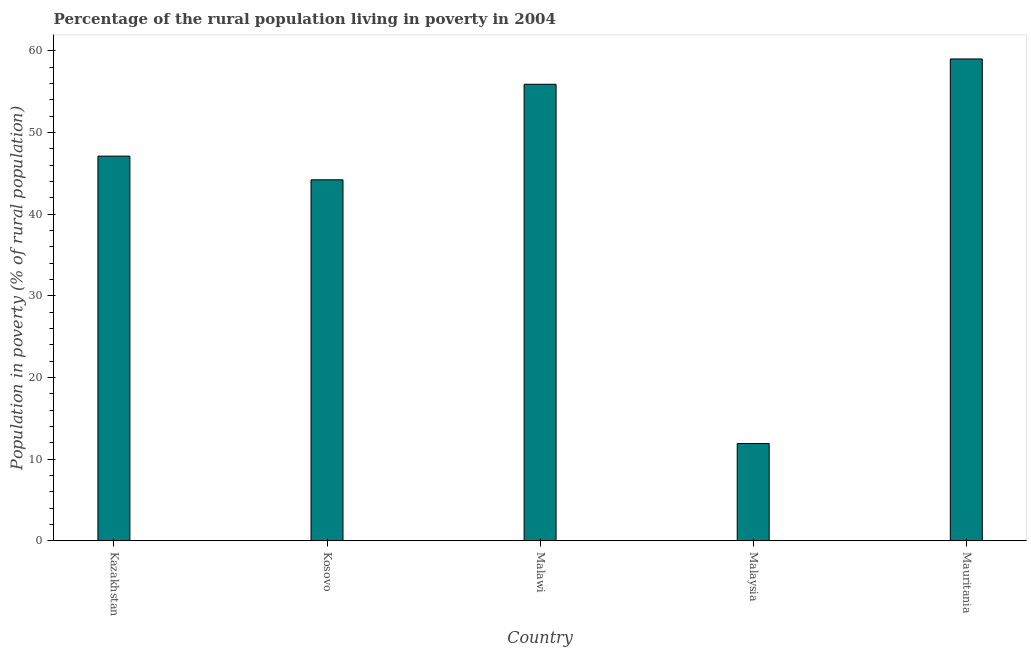Does the graph contain grids?
Your answer should be compact. No. What is the title of the graph?
Offer a very short reply. Percentage of the rural population living in poverty in 2004. What is the label or title of the X-axis?
Ensure brevity in your answer.  Country. What is the label or title of the Y-axis?
Offer a very short reply. Population in poverty (% of rural population). What is the percentage of rural population living below poverty line in Mauritania?
Offer a terse response. 59. Across all countries, what is the maximum percentage of rural population living below poverty line?
Provide a succinct answer. 59. Across all countries, what is the minimum percentage of rural population living below poverty line?
Your answer should be compact. 11.9. In which country was the percentage of rural population living below poverty line maximum?
Provide a succinct answer. Mauritania. In which country was the percentage of rural population living below poverty line minimum?
Keep it short and to the point. Malaysia. What is the sum of the percentage of rural population living below poverty line?
Offer a very short reply. 218.1. What is the difference between the percentage of rural population living below poverty line in Kazakhstan and Malaysia?
Give a very brief answer. 35.2. What is the average percentage of rural population living below poverty line per country?
Give a very brief answer. 43.62. What is the median percentage of rural population living below poverty line?
Offer a terse response. 47.1. What is the ratio of the percentage of rural population living below poverty line in Kosovo to that in Malawi?
Offer a terse response. 0.79. Is the percentage of rural population living below poverty line in Malaysia less than that in Mauritania?
Your answer should be very brief. Yes. Is the difference between the percentage of rural population living below poverty line in Malaysia and Mauritania greater than the difference between any two countries?
Give a very brief answer. Yes. What is the difference between the highest and the lowest percentage of rural population living below poverty line?
Your answer should be very brief. 47.1. In how many countries, is the percentage of rural population living below poverty line greater than the average percentage of rural population living below poverty line taken over all countries?
Make the answer very short. 4. How many countries are there in the graph?
Offer a very short reply. 5. What is the Population in poverty (% of rural population) of Kazakhstan?
Provide a short and direct response. 47.1. What is the Population in poverty (% of rural population) of Kosovo?
Your answer should be compact. 44.2. What is the Population in poverty (% of rural population) in Malawi?
Ensure brevity in your answer.  55.9. What is the difference between the Population in poverty (% of rural population) in Kazakhstan and Kosovo?
Make the answer very short. 2.9. What is the difference between the Population in poverty (% of rural population) in Kazakhstan and Malawi?
Provide a short and direct response. -8.8. What is the difference between the Population in poverty (% of rural population) in Kazakhstan and Malaysia?
Make the answer very short. 35.2. What is the difference between the Population in poverty (% of rural population) in Kosovo and Malawi?
Offer a terse response. -11.7. What is the difference between the Population in poverty (% of rural population) in Kosovo and Malaysia?
Make the answer very short. 32.3. What is the difference between the Population in poverty (% of rural population) in Kosovo and Mauritania?
Offer a very short reply. -14.8. What is the difference between the Population in poverty (% of rural population) in Malawi and Malaysia?
Offer a terse response. 44. What is the difference between the Population in poverty (% of rural population) in Malaysia and Mauritania?
Provide a succinct answer. -47.1. What is the ratio of the Population in poverty (% of rural population) in Kazakhstan to that in Kosovo?
Ensure brevity in your answer.  1.07. What is the ratio of the Population in poverty (% of rural population) in Kazakhstan to that in Malawi?
Offer a terse response. 0.84. What is the ratio of the Population in poverty (% of rural population) in Kazakhstan to that in Malaysia?
Give a very brief answer. 3.96. What is the ratio of the Population in poverty (% of rural population) in Kazakhstan to that in Mauritania?
Provide a short and direct response. 0.8. What is the ratio of the Population in poverty (% of rural population) in Kosovo to that in Malawi?
Your response must be concise. 0.79. What is the ratio of the Population in poverty (% of rural population) in Kosovo to that in Malaysia?
Give a very brief answer. 3.71. What is the ratio of the Population in poverty (% of rural population) in Kosovo to that in Mauritania?
Give a very brief answer. 0.75. What is the ratio of the Population in poverty (% of rural population) in Malawi to that in Malaysia?
Give a very brief answer. 4.7. What is the ratio of the Population in poverty (% of rural population) in Malawi to that in Mauritania?
Your answer should be compact. 0.95. What is the ratio of the Population in poverty (% of rural population) in Malaysia to that in Mauritania?
Provide a short and direct response. 0.2. 